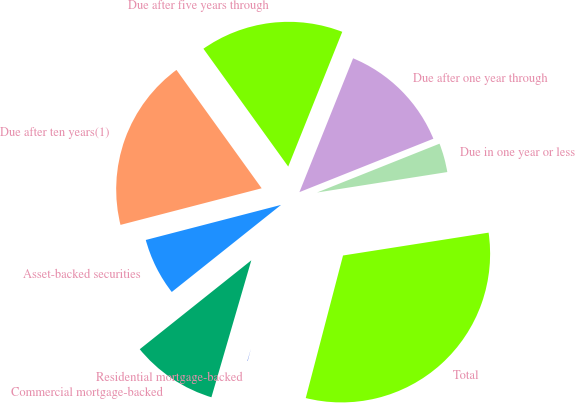<chart> <loc_0><loc_0><loc_500><loc_500><pie_chart><fcel>Due in one year or less<fcel>Due after one year through<fcel>Due after five years through<fcel>Due after ten years(1)<fcel>Asset-backed securities<fcel>Commercial mortgage-backed<fcel>Residential mortgage-backed<fcel>Total<nl><fcel>3.56%<fcel>12.89%<fcel>16.0%<fcel>19.11%<fcel>6.67%<fcel>9.78%<fcel>0.44%<fcel>31.55%<nl></chart> 